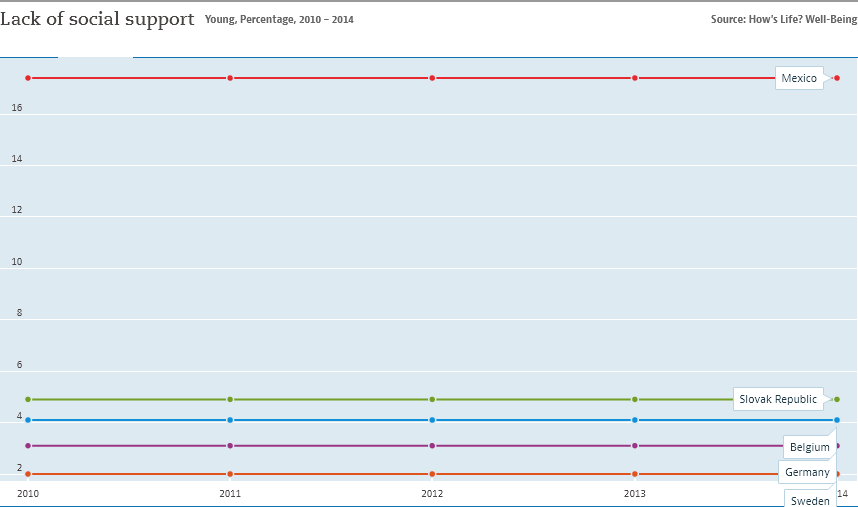Highlight a few significant elements in this photo. The value of lack of social support remains constant over time in Mexico. The data used to represent the graph come from 5 countries. 